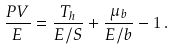Convert formula to latex. <formula><loc_0><loc_0><loc_500><loc_500>\frac { P V } { E } = \frac { T _ { h } } { E / S } + \frac { \mu _ { b } } { E / b } - 1 \, .</formula> 